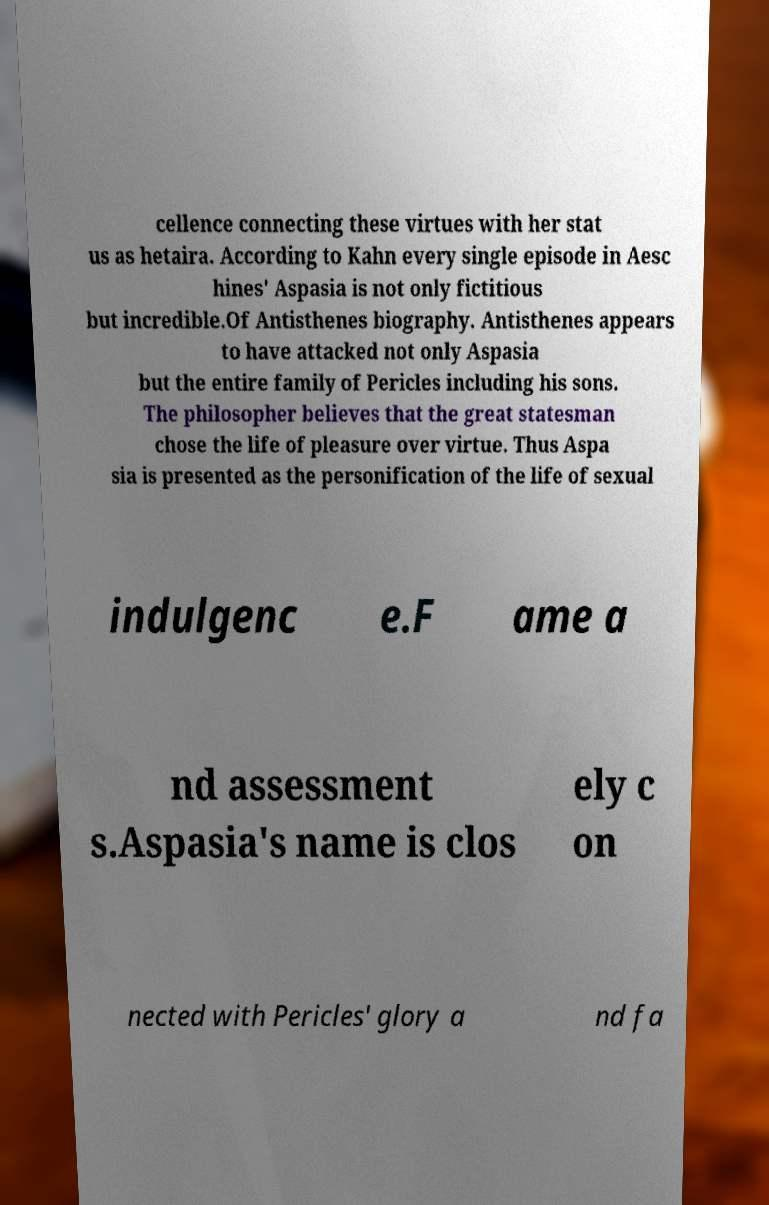What messages or text are displayed in this image? I need them in a readable, typed format. cellence connecting these virtues with her stat us as hetaira. According to Kahn every single episode in Aesc hines' Aspasia is not only fictitious but incredible.Of Antisthenes biography. Antisthenes appears to have attacked not only Aspasia but the entire family of Pericles including his sons. The philosopher believes that the great statesman chose the life of pleasure over virtue. Thus Aspa sia is presented as the personification of the life of sexual indulgenc e.F ame a nd assessment s.Aspasia's name is clos ely c on nected with Pericles' glory a nd fa 